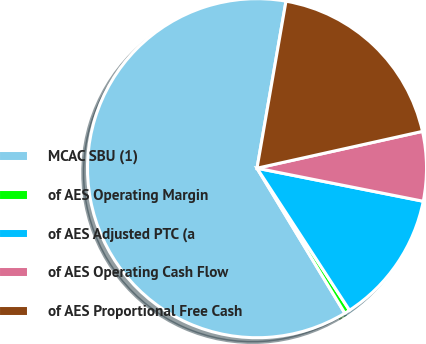<chart> <loc_0><loc_0><loc_500><loc_500><pie_chart><fcel>MCAC SBU (1)<fcel>of AES Operating Margin<fcel>of AES Adjusted PTC (a<fcel>of AES Operating Cash Flow<fcel>of AES Proportional Free Cash<nl><fcel>61.4%<fcel>0.52%<fcel>12.69%<fcel>6.61%<fcel>18.78%<nl></chart> 